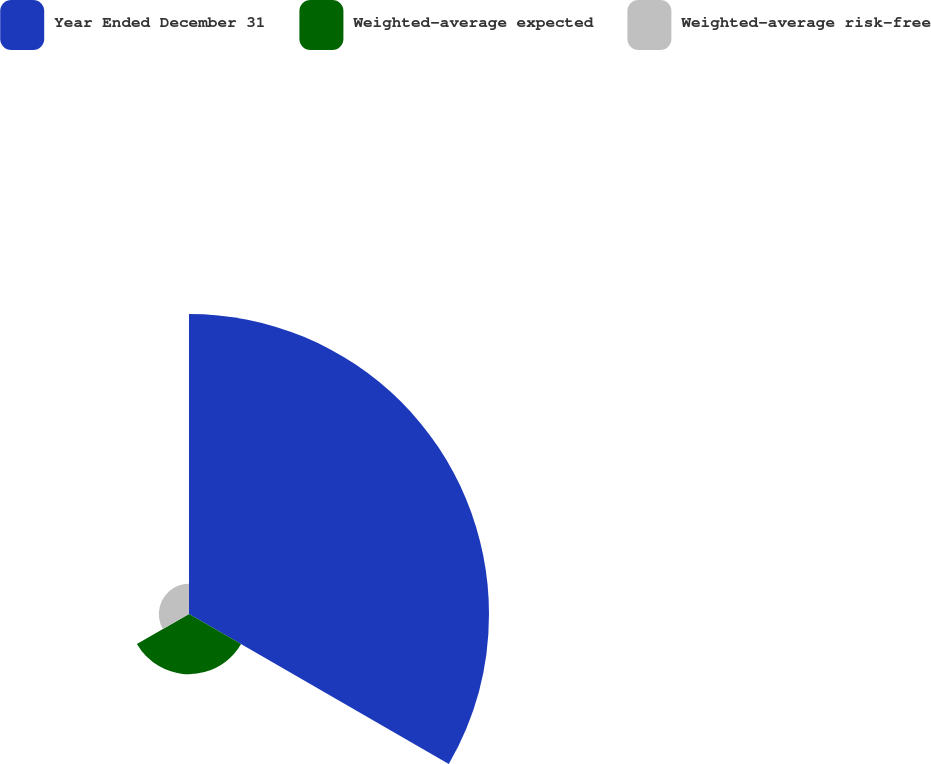<chart> <loc_0><loc_0><loc_500><loc_500><pie_chart><fcel>Year Ended December 31<fcel>Weighted-average expected<fcel>Weighted-average risk-free<nl><fcel>76.87%<fcel>15.41%<fcel>7.73%<nl></chart> 